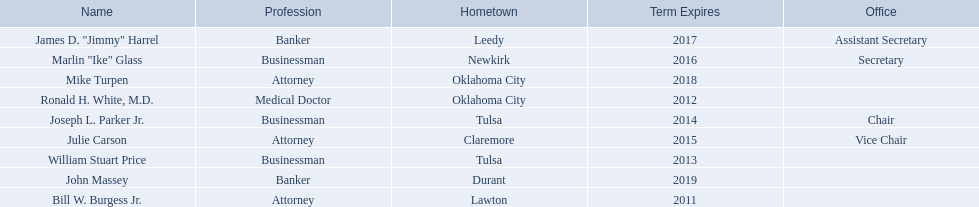What are all of the names? Bill W. Burgess Jr., Ronald H. White, M.D., William Stuart Price, Joseph L. Parker Jr., Julie Carson, Marlin "Ike" Glass, James D. "Jimmy" Harrel, Mike Turpen, John Massey. Where is each member from? Lawton, Oklahoma City, Tulsa, Tulsa, Claremore, Newkirk, Leedy, Oklahoma City, Durant. Along with joseph l. parker jr., which other member is from tulsa? William Stuart Price. 